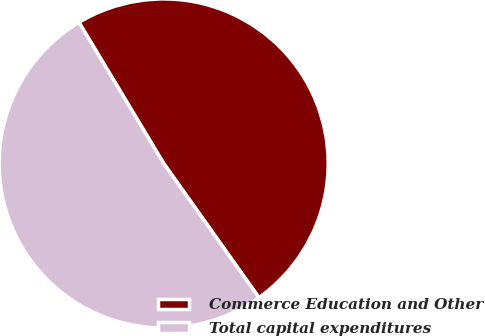Convert chart. <chart><loc_0><loc_0><loc_500><loc_500><pie_chart><fcel>Commerce Education and Other<fcel>Total capital expenditures<nl><fcel>48.78%<fcel>51.22%<nl></chart> 